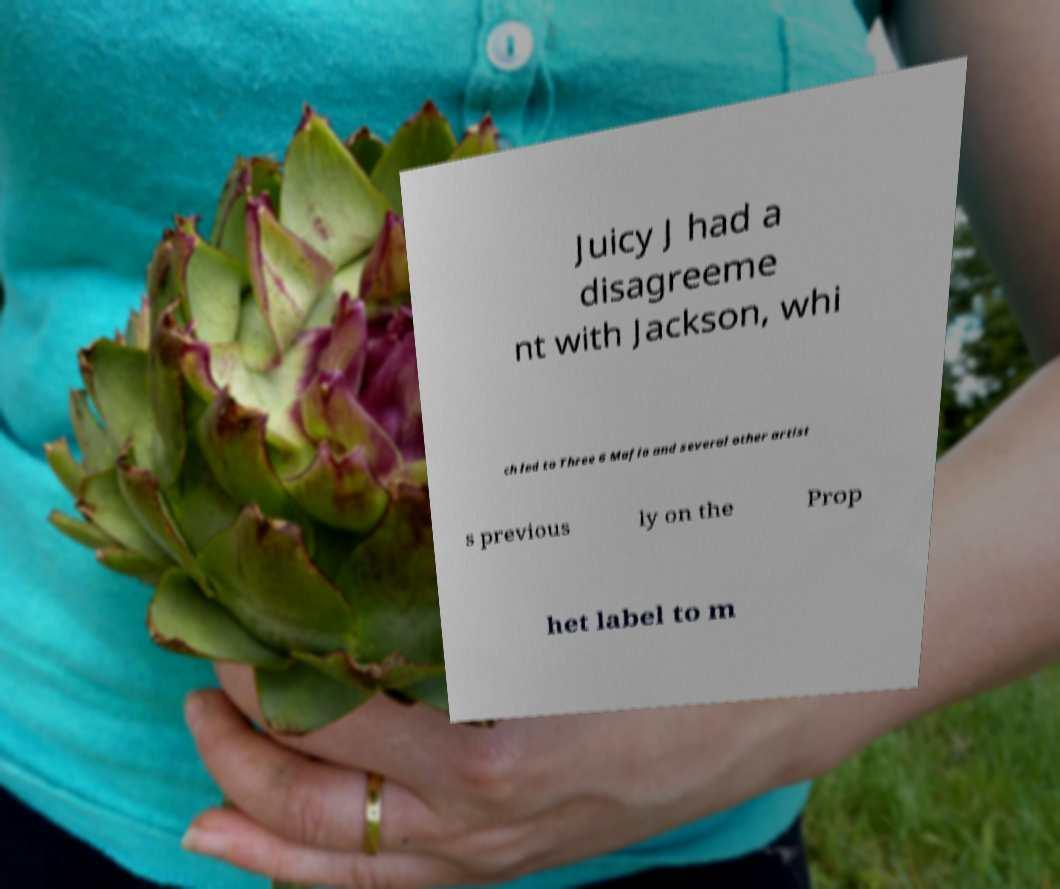Can you accurately transcribe the text from the provided image for me? Juicy J had a disagreeme nt with Jackson, whi ch led to Three 6 Mafia and several other artist s previous ly on the Prop het label to m 